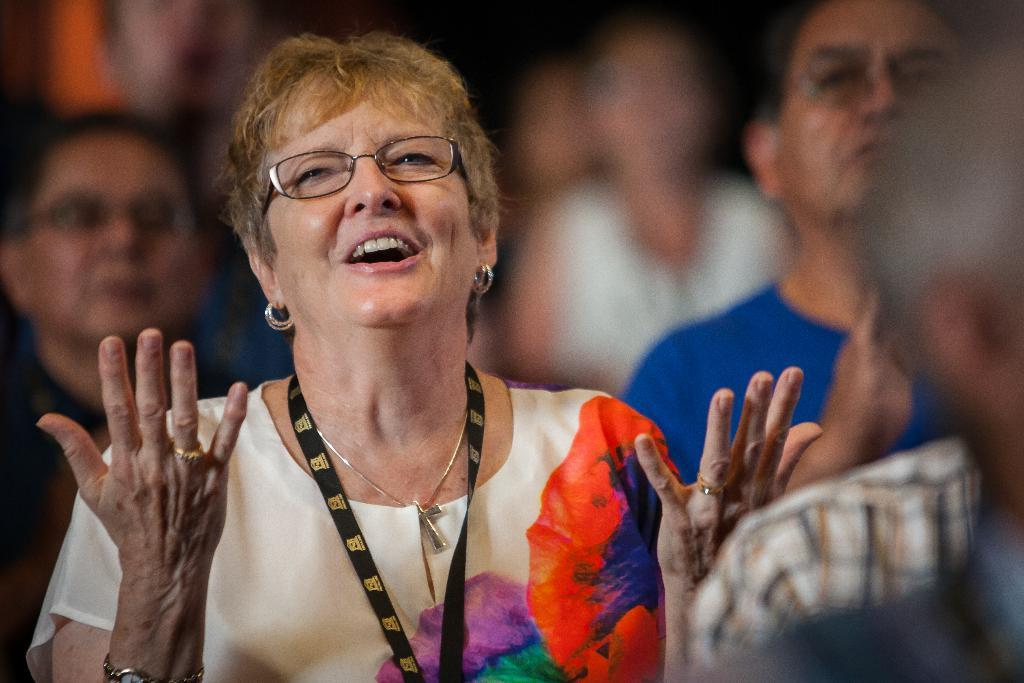How many people are in the image? There are people in the image, but the exact number is not specified. Can you describe the woman in the front of the image? The woman in the front of the image is wearing spectacles. What is the woman holding or wearing that identifies her? The woman has a tag. What religious symbol can be seen in the image? There is a Christianity symbol in the image. What is the temperature of the office in the image? There is no office present in the image, so it is not possible to determine the temperature. 